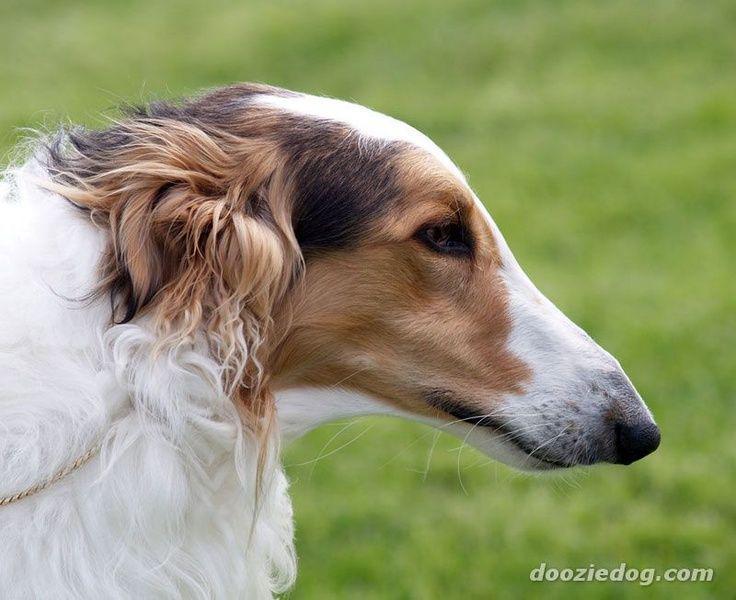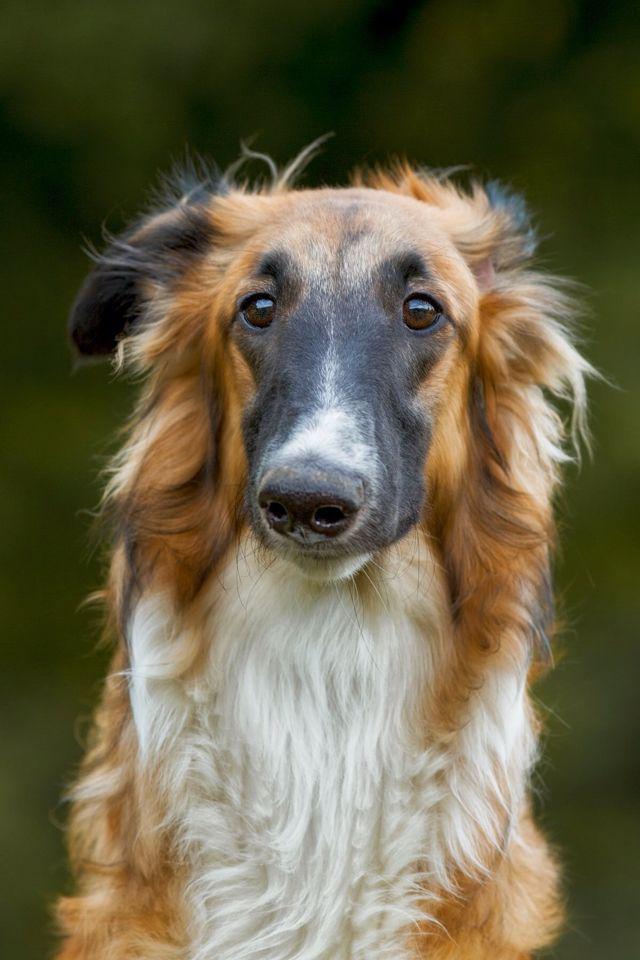The first image is the image on the left, the second image is the image on the right. Evaluate the accuracy of this statement regarding the images: "The left image is a profile with the dog facing right.". Is it true? Answer yes or no. Yes. 